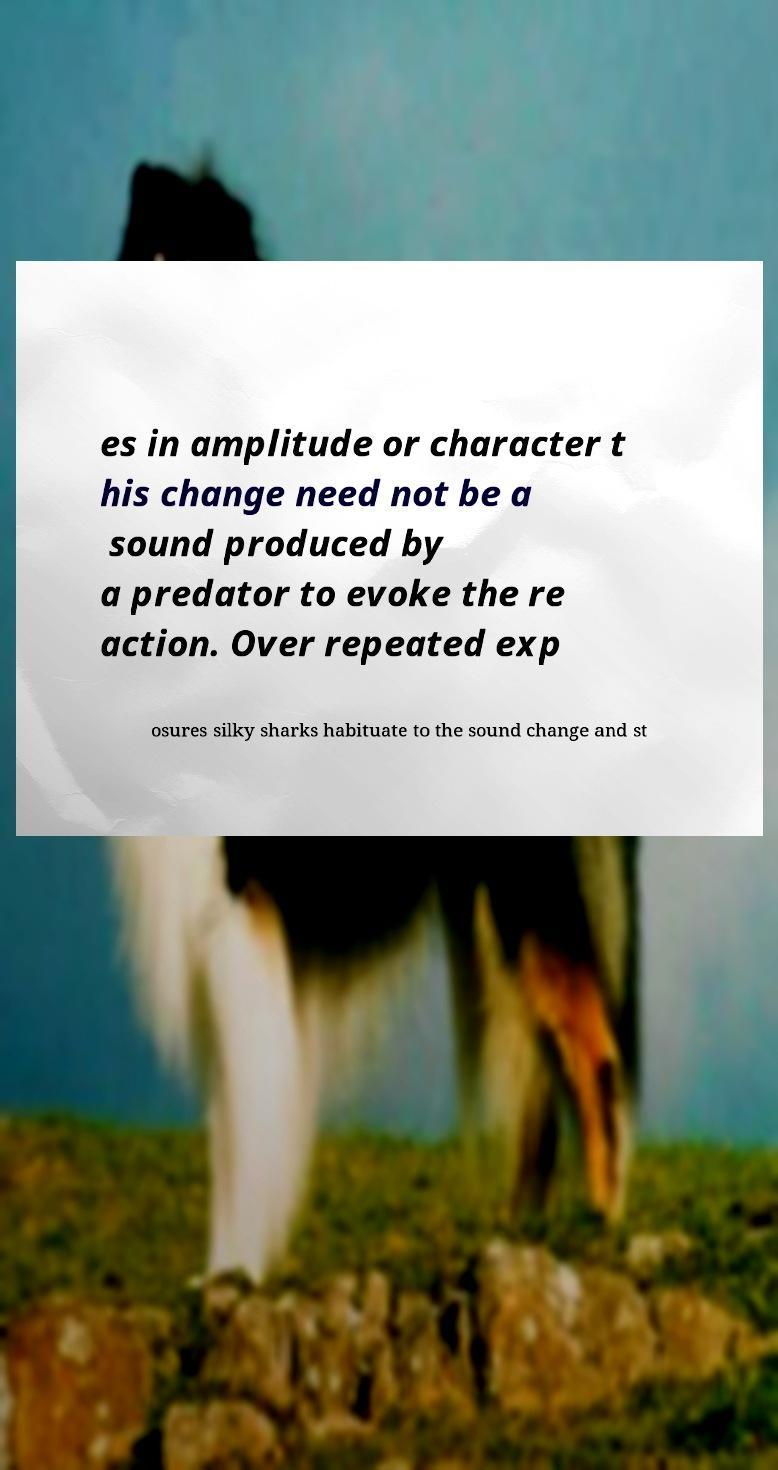Please read and relay the text visible in this image. What does it say? es in amplitude or character t his change need not be a sound produced by a predator to evoke the re action. Over repeated exp osures silky sharks habituate to the sound change and st 